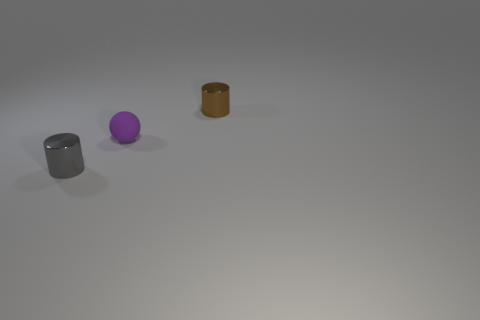What is the color of the sphere that is the same size as the gray metal object?
Keep it short and to the point. Purple. Is there a tiny purple rubber sphere?
Make the answer very short. Yes. Is the material of the tiny cylinder that is in front of the tiny matte object the same as the small brown object?
Keep it short and to the point. Yes. How many brown shiny things have the same size as the gray shiny thing?
Provide a succinct answer. 1. Is the number of shiny objects behind the purple sphere the same as the number of small blue metallic blocks?
Your answer should be very brief. No. What number of cylinders are both in front of the tiny purple thing and to the right of the tiny purple matte ball?
Provide a succinct answer. 0. There is a brown object that is the same material as the gray cylinder; what size is it?
Ensure brevity in your answer.  Small. How many purple rubber things have the same shape as the gray metal thing?
Offer a terse response. 0. Are there more small matte balls in front of the tiny brown object than cyan matte cylinders?
Provide a short and direct response. Yes. What is the shape of the tiny thing that is in front of the tiny brown object and right of the tiny gray shiny thing?
Make the answer very short. Sphere. 